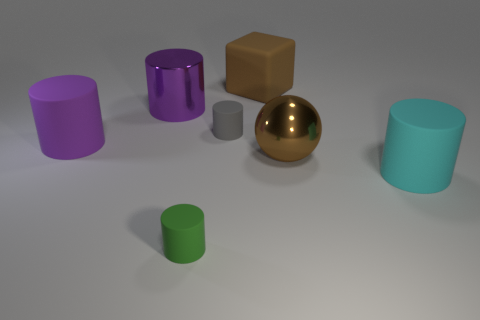Are there any other things that are made of the same material as the large brown sphere?
Your response must be concise. Yes. What shape is the large object that is the same color as the ball?
Your response must be concise. Cube. What is the material of the big brown thing behind the big brown thing on the right side of the matte cube that is behind the metallic cylinder?
Offer a terse response. Rubber. What is the shape of the purple matte object that is the same size as the cyan object?
Your answer should be very brief. Cylinder. Is there a metal cylinder of the same color as the cube?
Your answer should be compact. No. The green object is what size?
Ensure brevity in your answer.  Small. Are the green thing and the brown sphere made of the same material?
Your response must be concise. No. There is a large purple object that is behind the purple cylinder that is on the left side of the purple metal object; how many small gray cylinders are right of it?
Keep it short and to the point. 1. The large rubber thing behind the purple shiny cylinder has what shape?
Provide a short and direct response. Cube. What number of other things are there of the same material as the brown block
Your answer should be compact. 4. 